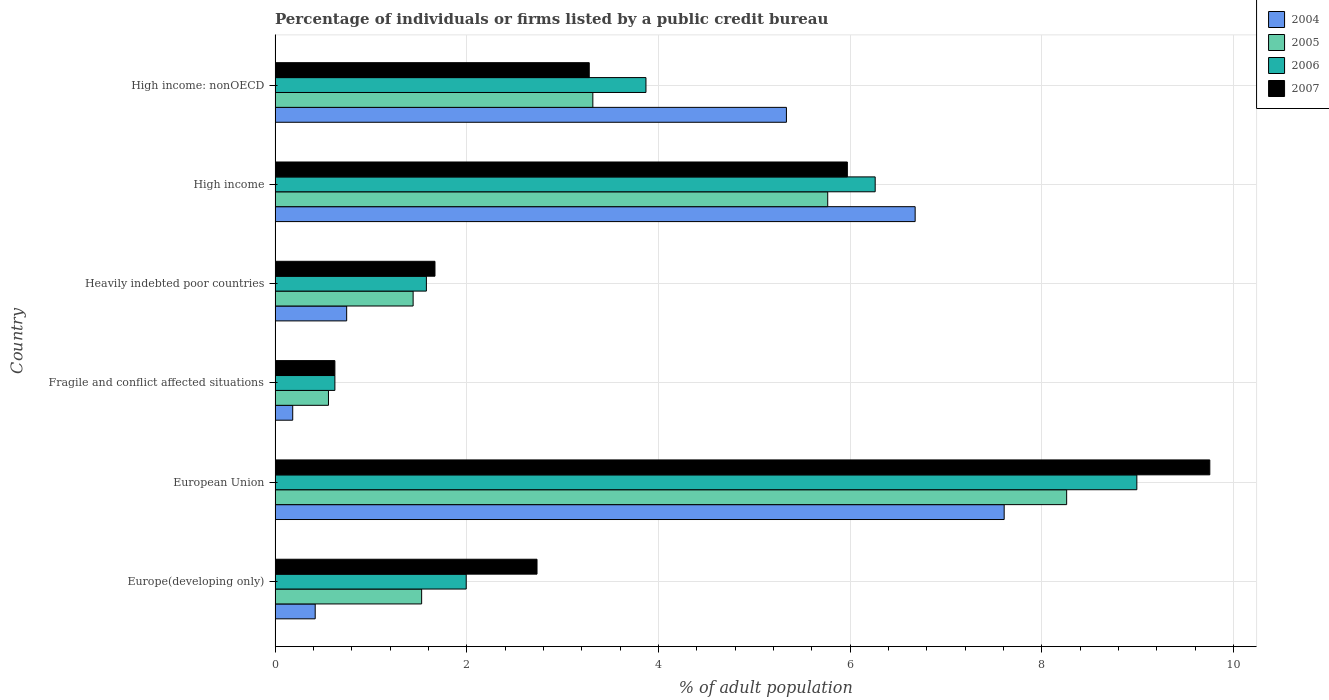Are the number of bars per tick equal to the number of legend labels?
Provide a short and direct response. Yes. Are the number of bars on each tick of the Y-axis equal?
Your response must be concise. Yes. How many bars are there on the 1st tick from the top?
Provide a succinct answer. 4. What is the label of the 6th group of bars from the top?
Provide a short and direct response. Europe(developing only). In how many cases, is the number of bars for a given country not equal to the number of legend labels?
Give a very brief answer. 0. What is the percentage of population listed by a public credit bureau in 2005 in High income: nonOECD?
Your response must be concise. 3.32. Across all countries, what is the maximum percentage of population listed by a public credit bureau in 2004?
Give a very brief answer. 7.61. Across all countries, what is the minimum percentage of population listed by a public credit bureau in 2007?
Your answer should be very brief. 0.62. In which country was the percentage of population listed by a public credit bureau in 2004 minimum?
Make the answer very short. Fragile and conflict affected situations. What is the total percentage of population listed by a public credit bureau in 2006 in the graph?
Provide a short and direct response. 23.32. What is the difference between the percentage of population listed by a public credit bureau in 2005 in Europe(developing only) and that in European Union?
Your answer should be very brief. -6.73. What is the difference between the percentage of population listed by a public credit bureau in 2004 in Europe(developing only) and the percentage of population listed by a public credit bureau in 2007 in European Union?
Give a very brief answer. -9.34. What is the average percentage of population listed by a public credit bureau in 2005 per country?
Provide a succinct answer. 3.48. What is the difference between the percentage of population listed by a public credit bureau in 2005 and percentage of population listed by a public credit bureau in 2004 in High income: nonOECD?
Provide a short and direct response. -2.02. What is the ratio of the percentage of population listed by a public credit bureau in 2004 in Europe(developing only) to that in Heavily indebted poor countries?
Your answer should be very brief. 0.56. Is the percentage of population listed by a public credit bureau in 2005 in European Union less than that in High income?
Offer a very short reply. No. What is the difference between the highest and the second highest percentage of population listed by a public credit bureau in 2007?
Your answer should be compact. 3.78. What is the difference between the highest and the lowest percentage of population listed by a public credit bureau in 2005?
Provide a short and direct response. 7.7. Is it the case that in every country, the sum of the percentage of population listed by a public credit bureau in 2006 and percentage of population listed by a public credit bureau in 2007 is greater than the sum of percentage of population listed by a public credit bureau in 2004 and percentage of population listed by a public credit bureau in 2005?
Offer a very short reply. No. What does the 4th bar from the bottom in Europe(developing only) represents?
Keep it short and to the point. 2007. How many bars are there?
Provide a short and direct response. 24. What is the difference between two consecutive major ticks on the X-axis?
Provide a short and direct response. 2. Are the values on the major ticks of X-axis written in scientific E-notation?
Provide a succinct answer. No. Does the graph contain grids?
Make the answer very short. Yes. What is the title of the graph?
Keep it short and to the point. Percentage of individuals or firms listed by a public credit bureau. What is the label or title of the X-axis?
Make the answer very short. % of adult population. What is the % of adult population in 2004 in Europe(developing only)?
Offer a very short reply. 0.42. What is the % of adult population of 2005 in Europe(developing only)?
Your answer should be compact. 1.53. What is the % of adult population in 2006 in Europe(developing only)?
Offer a very short reply. 1.99. What is the % of adult population in 2007 in Europe(developing only)?
Provide a short and direct response. 2.73. What is the % of adult population in 2004 in European Union?
Give a very brief answer. 7.61. What is the % of adult population in 2005 in European Union?
Offer a very short reply. 8.26. What is the % of adult population of 2006 in European Union?
Provide a short and direct response. 8.99. What is the % of adult population of 2007 in European Union?
Provide a succinct answer. 9.75. What is the % of adult population in 2004 in Fragile and conflict affected situations?
Ensure brevity in your answer.  0.18. What is the % of adult population in 2005 in Fragile and conflict affected situations?
Offer a very short reply. 0.56. What is the % of adult population in 2006 in Fragile and conflict affected situations?
Your answer should be very brief. 0.62. What is the % of adult population in 2007 in Fragile and conflict affected situations?
Provide a short and direct response. 0.62. What is the % of adult population in 2004 in Heavily indebted poor countries?
Provide a succinct answer. 0.75. What is the % of adult population of 2005 in Heavily indebted poor countries?
Give a very brief answer. 1.44. What is the % of adult population of 2006 in Heavily indebted poor countries?
Your response must be concise. 1.58. What is the % of adult population in 2007 in Heavily indebted poor countries?
Your response must be concise. 1.67. What is the % of adult population in 2004 in High income?
Make the answer very short. 6.68. What is the % of adult population in 2005 in High income?
Your answer should be compact. 5.77. What is the % of adult population in 2006 in High income?
Provide a short and direct response. 6.26. What is the % of adult population of 2007 in High income?
Make the answer very short. 5.97. What is the % of adult population of 2004 in High income: nonOECD?
Provide a short and direct response. 5.34. What is the % of adult population in 2005 in High income: nonOECD?
Offer a very short reply. 3.32. What is the % of adult population of 2006 in High income: nonOECD?
Your answer should be very brief. 3.87. What is the % of adult population of 2007 in High income: nonOECD?
Provide a succinct answer. 3.28. Across all countries, what is the maximum % of adult population in 2004?
Give a very brief answer. 7.61. Across all countries, what is the maximum % of adult population in 2005?
Provide a succinct answer. 8.26. Across all countries, what is the maximum % of adult population in 2006?
Ensure brevity in your answer.  8.99. Across all countries, what is the maximum % of adult population of 2007?
Your answer should be compact. 9.75. Across all countries, what is the minimum % of adult population of 2004?
Ensure brevity in your answer.  0.18. Across all countries, what is the minimum % of adult population of 2005?
Give a very brief answer. 0.56. Across all countries, what is the minimum % of adult population of 2006?
Offer a very short reply. 0.62. Across all countries, what is the minimum % of adult population of 2007?
Ensure brevity in your answer.  0.62. What is the total % of adult population in 2004 in the graph?
Your answer should be compact. 20.97. What is the total % of adult population in 2005 in the graph?
Offer a very short reply. 20.87. What is the total % of adult population in 2006 in the graph?
Offer a terse response. 23.32. What is the total % of adult population in 2007 in the graph?
Your answer should be very brief. 24.03. What is the difference between the % of adult population of 2004 in Europe(developing only) and that in European Union?
Ensure brevity in your answer.  -7.19. What is the difference between the % of adult population of 2005 in Europe(developing only) and that in European Union?
Your answer should be very brief. -6.73. What is the difference between the % of adult population of 2006 in Europe(developing only) and that in European Union?
Ensure brevity in your answer.  -7. What is the difference between the % of adult population of 2007 in Europe(developing only) and that in European Union?
Your answer should be compact. -7.02. What is the difference between the % of adult population in 2004 in Europe(developing only) and that in Fragile and conflict affected situations?
Make the answer very short. 0.23. What is the difference between the % of adult population in 2005 in Europe(developing only) and that in Fragile and conflict affected situations?
Your response must be concise. 0.97. What is the difference between the % of adult population in 2006 in Europe(developing only) and that in Fragile and conflict affected situations?
Ensure brevity in your answer.  1.37. What is the difference between the % of adult population of 2007 in Europe(developing only) and that in Fragile and conflict affected situations?
Offer a very short reply. 2.11. What is the difference between the % of adult population of 2004 in Europe(developing only) and that in Heavily indebted poor countries?
Give a very brief answer. -0.33. What is the difference between the % of adult population in 2005 in Europe(developing only) and that in Heavily indebted poor countries?
Offer a terse response. 0.09. What is the difference between the % of adult population of 2006 in Europe(developing only) and that in Heavily indebted poor countries?
Provide a short and direct response. 0.42. What is the difference between the % of adult population in 2007 in Europe(developing only) and that in Heavily indebted poor countries?
Your answer should be compact. 1.06. What is the difference between the % of adult population in 2004 in Europe(developing only) and that in High income?
Provide a short and direct response. -6.26. What is the difference between the % of adult population in 2005 in Europe(developing only) and that in High income?
Your answer should be very brief. -4.24. What is the difference between the % of adult population in 2006 in Europe(developing only) and that in High income?
Ensure brevity in your answer.  -4.27. What is the difference between the % of adult population in 2007 in Europe(developing only) and that in High income?
Offer a very short reply. -3.24. What is the difference between the % of adult population of 2004 in Europe(developing only) and that in High income: nonOECD?
Provide a succinct answer. -4.92. What is the difference between the % of adult population in 2005 in Europe(developing only) and that in High income: nonOECD?
Offer a very short reply. -1.79. What is the difference between the % of adult population in 2006 in Europe(developing only) and that in High income: nonOECD?
Offer a very short reply. -1.88. What is the difference between the % of adult population in 2007 in Europe(developing only) and that in High income: nonOECD?
Your response must be concise. -0.54. What is the difference between the % of adult population of 2004 in European Union and that in Fragile and conflict affected situations?
Keep it short and to the point. 7.42. What is the difference between the % of adult population of 2005 in European Union and that in Fragile and conflict affected situations?
Provide a short and direct response. 7.7. What is the difference between the % of adult population of 2006 in European Union and that in Fragile and conflict affected situations?
Give a very brief answer. 8.37. What is the difference between the % of adult population of 2007 in European Union and that in Fragile and conflict affected situations?
Ensure brevity in your answer.  9.13. What is the difference between the % of adult population of 2004 in European Union and that in Heavily indebted poor countries?
Offer a very short reply. 6.86. What is the difference between the % of adult population of 2005 in European Union and that in Heavily indebted poor countries?
Make the answer very short. 6.82. What is the difference between the % of adult population of 2006 in European Union and that in Heavily indebted poor countries?
Offer a very short reply. 7.41. What is the difference between the % of adult population of 2007 in European Union and that in Heavily indebted poor countries?
Provide a short and direct response. 8.09. What is the difference between the % of adult population of 2004 in European Union and that in High income?
Give a very brief answer. 0.93. What is the difference between the % of adult population in 2005 in European Union and that in High income?
Your answer should be very brief. 2.49. What is the difference between the % of adult population in 2006 in European Union and that in High income?
Offer a very short reply. 2.73. What is the difference between the % of adult population of 2007 in European Union and that in High income?
Provide a short and direct response. 3.78. What is the difference between the % of adult population of 2004 in European Union and that in High income: nonOECD?
Make the answer very short. 2.27. What is the difference between the % of adult population of 2005 in European Union and that in High income: nonOECD?
Your answer should be compact. 4.94. What is the difference between the % of adult population of 2006 in European Union and that in High income: nonOECD?
Provide a short and direct response. 5.12. What is the difference between the % of adult population in 2007 in European Union and that in High income: nonOECD?
Provide a succinct answer. 6.48. What is the difference between the % of adult population in 2004 in Fragile and conflict affected situations and that in Heavily indebted poor countries?
Offer a very short reply. -0.56. What is the difference between the % of adult population of 2005 in Fragile and conflict affected situations and that in Heavily indebted poor countries?
Provide a succinct answer. -0.88. What is the difference between the % of adult population of 2006 in Fragile and conflict affected situations and that in Heavily indebted poor countries?
Keep it short and to the point. -0.95. What is the difference between the % of adult population in 2007 in Fragile and conflict affected situations and that in Heavily indebted poor countries?
Ensure brevity in your answer.  -1.04. What is the difference between the % of adult population of 2004 in Fragile and conflict affected situations and that in High income?
Give a very brief answer. -6.5. What is the difference between the % of adult population of 2005 in Fragile and conflict affected situations and that in High income?
Your response must be concise. -5.21. What is the difference between the % of adult population in 2006 in Fragile and conflict affected situations and that in High income?
Provide a short and direct response. -5.64. What is the difference between the % of adult population of 2007 in Fragile and conflict affected situations and that in High income?
Offer a terse response. -5.35. What is the difference between the % of adult population of 2004 in Fragile and conflict affected situations and that in High income: nonOECD?
Offer a terse response. -5.15. What is the difference between the % of adult population in 2005 in Fragile and conflict affected situations and that in High income: nonOECD?
Make the answer very short. -2.76. What is the difference between the % of adult population in 2006 in Fragile and conflict affected situations and that in High income: nonOECD?
Keep it short and to the point. -3.25. What is the difference between the % of adult population of 2007 in Fragile and conflict affected situations and that in High income: nonOECD?
Provide a short and direct response. -2.65. What is the difference between the % of adult population of 2004 in Heavily indebted poor countries and that in High income?
Make the answer very short. -5.93. What is the difference between the % of adult population in 2005 in Heavily indebted poor countries and that in High income?
Provide a short and direct response. -4.33. What is the difference between the % of adult population in 2006 in Heavily indebted poor countries and that in High income?
Provide a succinct answer. -4.68. What is the difference between the % of adult population in 2007 in Heavily indebted poor countries and that in High income?
Ensure brevity in your answer.  -4.3. What is the difference between the % of adult population of 2004 in Heavily indebted poor countries and that in High income: nonOECD?
Provide a succinct answer. -4.59. What is the difference between the % of adult population in 2005 in Heavily indebted poor countries and that in High income: nonOECD?
Make the answer very short. -1.88. What is the difference between the % of adult population in 2006 in Heavily indebted poor countries and that in High income: nonOECD?
Give a very brief answer. -2.29. What is the difference between the % of adult population in 2007 in Heavily indebted poor countries and that in High income: nonOECD?
Offer a terse response. -1.61. What is the difference between the % of adult population in 2004 in High income and that in High income: nonOECD?
Offer a terse response. 1.34. What is the difference between the % of adult population of 2005 in High income and that in High income: nonOECD?
Your response must be concise. 2.45. What is the difference between the % of adult population in 2006 in High income and that in High income: nonOECD?
Make the answer very short. 2.39. What is the difference between the % of adult population of 2007 in High income and that in High income: nonOECD?
Ensure brevity in your answer.  2.69. What is the difference between the % of adult population of 2004 in Europe(developing only) and the % of adult population of 2005 in European Union?
Your answer should be compact. -7.84. What is the difference between the % of adult population in 2004 in Europe(developing only) and the % of adult population in 2006 in European Union?
Offer a terse response. -8.57. What is the difference between the % of adult population of 2004 in Europe(developing only) and the % of adult population of 2007 in European Union?
Make the answer very short. -9.34. What is the difference between the % of adult population in 2005 in Europe(developing only) and the % of adult population in 2006 in European Union?
Offer a terse response. -7.46. What is the difference between the % of adult population of 2005 in Europe(developing only) and the % of adult population of 2007 in European Union?
Offer a very short reply. -8.22. What is the difference between the % of adult population in 2006 in Europe(developing only) and the % of adult population in 2007 in European Union?
Offer a terse response. -7.76. What is the difference between the % of adult population in 2004 in Europe(developing only) and the % of adult population in 2005 in Fragile and conflict affected situations?
Provide a succinct answer. -0.14. What is the difference between the % of adult population in 2004 in Europe(developing only) and the % of adult population in 2006 in Fragile and conflict affected situations?
Make the answer very short. -0.21. What is the difference between the % of adult population of 2004 in Europe(developing only) and the % of adult population of 2007 in Fragile and conflict affected situations?
Provide a succinct answer. -0.21. What is the difference between the % of adult population of 2005 in Europe(developing only) and the % of adult population of 2006 in Fragile and conflict affected situations?
Keep it short and to the point. 0.91. What is the difference between the % of adult population in 2005 in Europe(developing only) and the % of adult population in 2007 in Fragile and conflict affected situations?
Give a very brief answer. 0.91. What is the difference between the % of adult population of 2006 in Europe(developing only) and the % of adult population of 2007 in Fragile and conflict affected situations?
Offer a very short reply. 1.37. What is the difference between the % of adult population in 2004 in Europe(developing only) and the % of adult population in 2005 in Heavily indebted poor countries?
Provide a short and direct response. -1.02. What is the difference between the % of adult population in 2004 in Europe(developing only) and the % of adult population in 2006 in Heavily indebted poor countries?
Offer a very short reply. -1.16. What is the difference between the % of adult population of 2004 in Europe(developing only) and the % of adult population of 2007 in Heavily indebted poor countries?
Give a very brief answer. -1.25. What is the difference between the % of adult population in 2005 in Europe(developing only) and the % of adult population in 2006 in Heavily indebted poor countries?
Your answer should be very brief. -0.05. What is the difference between the % of adult population in 2005 in Europe(developing only) and the % of adult population in 2007 in Heavily indebted poor countries?
Provide a short and direct response. -0.14. What is the difference between the % of adult population in 2006 in Europe(developing only) and the % of adult population in 2007 in Heavily indebted poor countries?
Provide a succinct answer. 0.33. What is the difference between the % of adult population in 2004 in Europe(developing only) and the % of adult population in 2005 in High income?
Your answer should be very brief. -5.35. What is the difference between the % of adult population in 2004 in Europe(developing only) and the % of adult population in 2006 in High income?
Offer a very short reply. -5.84. What is the difference between the % of adult population in 2004 in Europe(developing only) and the % of adult population in 2007 in High income?
Make the answer very short. -5.55. What is the difference between the % of adult population in 2005 in Europe(developing only) and the % of adult population in 2006 in High income?
Your response must be concise. -4.73. What is the difference between the % of adult population in 2005 in Europe(developing only) and the % of adult population in 2007 in High income?
Offer a terse response. -4.44. What is the difference between the % of adult population in 2006 in Europe(developing only) and the % of adult population in 2007 in High income?
Offer a very short reply. -3.98. What is the difference between the % of adult population of 2004 in Europe(developing only) and the % of adult population of 2005 in High income: nonOECD?
Your answer should be compact. -2.9. What is the difference between the % of adult population of 2004 in Europe(developing only) and the % of adult population of 2006 in High income: nonOECD?
Keep it short and to the point. -3.45. What is the difference between the % of adult population in 2004 in Europe(developing only) and the % of adult population in 2007 in High income: nonOECD?
Keep it short and to the point. -2.86. What is the difference between the % of adult population in 2005 in Europe(developing only) and the % of adult population in 2006 in High income: nonOECD?
Offer a terse response. -2.34. What is the difference between the % of adult population in 2005 in Europe(developing only) and the % of adult population in 2007 in High income: nonOECD?
Provide a short and direct response. -1.75. What is the difference between the % of adult population in 2006 in Europe(developing only) and the % of adult population in 2007 in High income: nonOECD?
Keep it short and to the point. -1.28. What is the difference between the % of adult population in 2004 in European Union and the % of adult population in 2005 in Fragile and conflict affected situations?
Make the answer very short. 7.05. What is the difference between the % of adult population in 2004 in European Union and the % of adult population in 2006 in Fragile and conflict affected situations?
Offer a terse response. 6.98. What is the difference between the % of adult population in 2004 in European Union and the % of adult population in 2007 in Fragile and conflict affected situations?
Ensure brevity in your answer.  6.98. What is the difference between the % of adult population of 2005 in European Union and the % of adult population of 2006 in Fragile and conflict affected situations?
Your answer should be very brief. 7.64. What is the difference between the % of adult population in 2005 in European Union and the % of adult population in 2007 in Fragile and conflict affected situations?
Your answer should be compact. 7.64. What is the difference between the % of adult population of 2006 in European Union and the % of adult population of 2007 in Fragile and conflict affected situations?
Give a very brief answer. 8.37. What is the difference between the % of adult population in 2004 in European Union and the % of adult population in 2005 in Heavily indebted poor countries?
Provide a succinct answer. 6.17. What is the difference between the % of adult population in 2004 in European Union and the % of adult population in 2006 in Heavily indebted poor countries?
Provide a short and direct response. 6.03. What is the difference between the % of adult population in 2004 in European Union and the % of adult population in 2007 in Heavily indebted poor countries?
Your answer should be compact. 5.94. What is the difference between the % of adult population of 2005 in European Union and the % of adult population of 2006 in Heavily indebted poor countries?
Give a very brief answer. 6.68. What is the difference between the % of adult population in 2005 in European Union and the % of adult population in 2007 in Heavily indebted poor countries?
Offer a terse response. 6.59. What is the difference between the % of adult population of 2006 in European Union and the % of adult population of 2007 in Heavily indebted poor countries?
Keep it short and to the point. 7.32. What is the difference between the % of adult population in 2004 in European Union and the % of adult population in 2005 in High income?
Provide a succinct answer. 1.84. What is the difference between the % of adult population of 2004 in European Union and the % of adult population of 2006 in High income?
Offer a very short reply. 1.35. What is the difference between the % of adult population of 2004 in European Union and the % of adult population of 2007 in High income?
Your answer should be very brief. 1.64. What is the difference between the % of adult population in 2005 in European Union and the % of adult population in 2006 in High income?
Ensure brevity in your answer.  2. What is the difference between the % of adult population in 2005 in European Union and the % of adult population in 2007 in High income?
Your response must be concise. 2.29. What is the difference between the % of adult population of 2006 in European Union and the % of adult population of 2007 in High income?
Provide a succinct answer. 3.02. What is the difference between the % of adult population of 2004 in European Union and the % of adult population of 2005 in High income: nonOECD?
Keep it short and to the point. 4.29. What is the difference between the % of adult population in 2004 in European Union and the % of adult population in 2006 in High income: nonOECD?
Your answer should be compact. 3.74. What is the difference between the % of adult population in 2004 in European Union and the % of adult population in 2007 in High income: nonOECD?
Give a very brief answer. 4.33. What is the difference between the % of adult population of 2005 in European Union and the % of adult population of 2006 in High income: nonOECD?
Your answer should be compact. 4.39. What is the difference between the % of adult population in 2005 in European Union and the % of adult population in 2007 in High income: nonOECD?
Ensure brevity in your answer.  4.98. What is the difference between the % of adult population in 2006 in European Union and the % of adult population in 2007 in High income: nonOECD?
Your answer should be compact. 5.71. What is the difference between the % of adult population in 2004 in Fragile and conflict affected situations and the % of adult population in 2005 in Heavily indebted poor countries?
Offer a very short reply. -1.26. What is the difference between the % of adult population of 2004 in Fragile and conflict affected situations and the % of adult population of 2006 in Heavily indebted poor countries?
Keep it short and to the point. -1.39. What is the difference between the % of adult population of 2004 in Fragile and conflict affected situations and the % of adult population of 2007 in Heavily indebted poor countries?
Your answer should be very brief. -1.48. What is the difference between the % of adult population in 2005 in Fragile and conflict affected situations and the % of adult population in 2006 in Heavily indebted poor countries?
Your answer should be compact. -1.02. What is the difference between the % of adult population of 2005 in Fragile and conflict affected situations and the % of adult population of 2007 in Heavily indebted poor countries?
Give a very brief answer. -1.11. What is the difference between the % of adult population in 2006 in Fragile and conflict affected situations and the % of adult population in 2007 in Heavily indebted poor countries?
Make the answer very short. -1.04. What is the difference between the % of adult population in 2004 in Fragile and conflict affected situations and the % of adult population in 2005 in High income?
Offer a terse response. -5.58. What is the difference between the % of adult population in 2004 in Fragile and conflict affected situations and the % of adult population in 2006 in High income?
Give a very brief answer. -6.08. What is the difference between the % of adult population of 2004 in Fragile and conflict affected situations and the % of adult population of 2007 in High income?
Make the answer very short. -5.79. What is the difference between the % of adult population in 2005 in Fragile and conflict affected situations and the % of adult population in 2006 in High income?
Your response must be concise. -5.7. What is the difference between the % of adult population in 2005 in Fragile and conflict affected situations and the % of adult population in 2007 in High income?
Make the answer very short. -5.41. What is the difference between the % of adult population in 2006 in Fragile and conflict affected situations and the % of adult population in 2007 in High income?
Your answer should be compact. -5.35. What is the difference between the % of adult population of 2004 in Fragile and conflict affected situations and the % of adult population of 2005 in High income: nonOECD?
Ensure brevity in your answer.  -3.13. What is the difference between the % of adult population in 2004 in Fragile and conflict affected situations and the % of adult population in 2006 in High income: nonOECD?
Your response must be concise. -3.69. What is the difference between the % of adult population of 2004 in Fragile and conflict affected situations and the % of adult population of 2007 in High income: nonOECD?
Your answer should be very brief. -3.09. What is the difference between the % of adult population in 2005 in Fragile and conflict affected situations and the % of adult population in 2006 in High income: nonOECD?
Ensure brevity in your answer.  -3.31. What is the difference between the % of adult population of 2005 in Fragile and conflict affected situations and the % of adult population of 2007 in High income: nonOECD?
Your response must be concise. -2.72. What is the difference between the % of adult population of 2006 in Fragile and conflict affected situations and the % of adult population of 2007 in High income: nonOECD?
Provide a short and direct response. -2.65. What is the difference between the % of adult population of 2004 in Heavily indebted poor countries and the % of adult population of 2005 in High income?
Offer a terse response. -5.02. What is the difference between the % of adult population in 2004 in Heavily indebted poor countries and the % of adult population in 2006 in High income?
Provide a short and direct response. -5.51. What is the difference between the % of adult population of 2004 in Heavily indebted poor countries and the % of adult population of 2007 in High income?
Make the answer very short. -5.22. What is the difference between the % of adult population in 2005 in Heavily indebted poor countries and the % of adult population in 2006 in High income?
Ensure brevity in your answer.  -4.82. What is the difference between the % of adult population of 2005 in Heavily indebted poor countries and the % of adult population of 2007 in High income?
Ensure brevity in your answer.  -4.53. What is the difference between the % of adult population of 2006 in Heavily indebted poor countries and the % of adult population of 2007 in High income?
Keep it short and to the point. -4.39. What is the difference between the % of adult population of 2004 in Heavily indebted poor countries and the % of adult population of 2005 in High income: nonOECD?
Your response must be concise. -2.57. What is the difference between the % of adult population in 2004 in Heavily indebted poor countries and the % of adult population in 2006 in High income: nonOECD?
Provide a succinct answer. -3.12. What is the difference between the % of adult population in 2004 in Heavily indebted poor countries and the % of adult population in 2007 in High income: nonOECD?
Your answer should be compact. -2.53. What is the difference between the % of adult population of 2005 in Heavily indebted poor countries and the % of adult population of 2006 in High income: nonOECD?
Your answer should be compact. -2.43. What is the difference between the % of adult population in 2005 in Heavily indebted poor countries and the % of adult population in 2007 in High income: nonOECD?
Provide a succinct answer. -1.84. What is the difference between the % of adult population in 2006 in Heavily indebted poor countries and the % of adult population in 2007 in High income: nonOECD?
Make the answer very short. -1.7. What is the difference between the % of adult population in 2004 in High income and the % of adult population in 2005 in High income: nonOECD?
Your response must be concise. 3.36. What is the difference between the % of adult population of 2004 in High income and the % of adult population of 2006 in High income: nonOECD?
Offer a terse response. 2.81. What is the difference between the % of adult population of 2004 in High income and the % of adult population of 2007 in High income: nonOECD?
Your answer should be very brief. 3.4. What is the difference between the % of adult population in 2005 in High income and the % of adult population in 2006 in High income: nonOECD?
Your answer should be very brief. 1.9. What is the difference between the % of adult population in 2005 in High income and the % of adult population in 2007 in High income: nonOECD?
Make the answer very short. 2.49. What is the difference between the % of adult population in 2006 in High income and the % of adult population in 2007 in High income: nonOECD?
Offer a very short reply. 2.98. What is the average % of adult population in 2004 per country?
Make the answer very short. 3.5. What is the average % of adult population in 2005 per country?
Your answer should be very brief. 3.48. What is the average % of adult population of 2006 per country?
Your answer should be very brief. 3.89. What is the average % of adult population of 2007 per country?
Your answer should be compact. 4. What is the difference between the % of adult population of 2004 and % of adult population of 2005 in Europe(developing only)?
Provide a succinct answer. -1.11. What is the difference between the % of adult population in 2004 and % of adult population in 2006 in Europe(developing only)?
Offer a very short reply. -1.58. What is the difference between the % of adult population of 2004 and % of adult population of 2007 in Europe(developing only)?
Your response must be concise. -2.31. What is the difference between the % of adult population of 2005 and % of adult population of 2006 in Europe(developing only)?
Your answer should be very brief. -0.47. What is the difference between the % of adult population in 2005 and % of adult population in 2007 in Europe(developing only)?
Make the answer very short. -1.2. What is the difference between the % of adult population of 2006 and % of adult population of 2007 in Europe(developing only)?
Ensure brevity in your answer.  -0.74. What is the difference between the % of adult population in 2004 and % of adult population in 2005 in European Union?
Give a very brief answer. -0.65. What is the difference between the % of adult population in 2004 and % of adult population in 2006 in European Union?
Keep it short and to the point. -1.38. What is the difference between the % of adult population in 2004 and % of adult population in 2007 in European Union?
Offer a very short reply. -2.15. What is the difference between the % of adult population of 2005 and % of adult population of 2006 in European Union?
Your answer should be compact. -0.73. What is the difference between the % of adult population of 2005 and % of adult population of 2007 in European Union?
Make the answer very short. -1.49. What is the difference between the % of adult population in 2006 and % of adult population in 2007 in European Union?
Ensure brevity in your answer.  -0.76. What is the difference between the % of adult population in 2004 and % of adult population in 2005 in Fragile and conflict affected situations?
Make the answer very short. -0.37. What is the difference between the % of adult population of 2004 and % of adult population of 2006 in Fragile and conflict affected situations?
Your response must be concise. -0.44. What is the difference between the % of adult population of 2004 and % of adult population of 2007 in Fragile and conflict affected situations?
Offer a terse response. -0.44. What is the difference between the % of adult population in 2005 and % of adult population in 2006 in Fragile and conflict affected situations?
Provide a succinct answer. -0.07. What is the difference between the % of adult population of 2005 and % of adult population of 2007 in Fragile and conflict affected situations?
Ensure brevity in your answer.  -0.07. What is the difference between the % of adult population of 2006 and % of adult population of 2007 in Fragile and conflict affected situations?
Offer a terse response. 0. What is the difference between the % of adult population of 2004 and % of adult population of 2005 in Heavily indebted poor countries?
Keep it short and to the point. -0.69. What is the difference between the % of adult population in 2004 and % of adult population in 2006 in Heavily indebted poor countries?
Ensure brevity in your answer.  -0.83. What is the difference between the % of adult population of 2004 and % of adult population of 2007 in Heavily indebted poor countries?
Your answer should be very brief. -0.92. What is the difference between the % of adult population in 2005 and % of adult population in 2006 in Heavily indebted poor countries?
Offer a very short reply. -0.14. What is the difference between the % of adult population of 2005 and % of adult population of 2007 in Heavily indebted poor countries?
Your answer should be very brief. -0.23. What is the difference between the % of adult population in 2006 and % of adult population in 2007 in Heavily indebted poor countries?
Your answer should be compact. -0.09. What is the difference between the % of adult population of 2004 and % of adult population of 2005 in High income?
Ensure brevity in your answer.  0.91. What is the difference between the % of adult population in 2004 and % of adult population in 2006 in High income?
Provide a succinct answer. 0.42. What is the difference between the % of adult population of 2004 and % of adult population of 2007 in High income?
Provide a short and direct response. 0.71. What is the difference between the % of adult population in 2005 and % of adult population in 2006 in High income?
Offer a very short reply. -0.5. What is the difference between the % of adult population in 2005 and % of adult population in 2007 in High income?
Keep it short and to the point. -0.2. What is the difference between the % of adult population of 2006 and % of adult population of 2007 in High income?
Provide a short and direct response. 0.29. What is the difference between the % of adult population of 2004 and % of adult population of 2005 in High income: nonOECD?
Your answer should be very brief. 2.02. What is the difference between the % of adult population in 2004 and % of adult population in 2006 in High income: nonOECD?
Your response must be concise. 1.47. What is the difference between the % of adult population in 2004 and % of adult population in 2007 in High income: nonOECD?
Give a very brief answer. 2.06. What is the difference between the % of adult population of 2005 and % of adult population of 2006 in High income: nonOECD?
Provide a succinct answer. -0.55. What is the difference between the % of adult population of 2005 and % of adult population of 2007 in High income: nonOECD?
Your response must be concise. 0.04. What is the difference between the % of adult population of 2006 and % of adult population of 2007 in High income: nonOECD?
Ensure brevity in your answer.  0.59. What is the ratio of the % of adult population of 2004 in Europe(developing only) to that in European Union?
Make the answer very short. 0.06. What is the ratio of the % of adult population of 2005 in Europe(developing only) to that in European Union?
Give a very brief answer. 0.19. What is the ratio of the % of adult population in 2006 in Europe(developing only) to that in European Union?
Offer a very short reply. 0.22. What is the ratio of the % of adult population in 2007 in Europe(developing only) to that in European Union?
Your response must be concise. 0.28. What is the ratio of the % of adult population in 2004 in Europe(developing only) to that in Fragile and conflict affected situations?
Give a very brief answer. 2.28. What is the ratio of the % of adult population in 2005 in Europe(developing only) to that in Fragile and conflict affected situations?
Make the answer very short. 2.75. What is the ratio of the % of adult population of 2006 in Europe(developing only) to that in Fragile and conflict affected situations?
Provide a short and direct response. 3.2. What is the ratio of the % of adult population of 2007 in Europe(developing only) to that in Fragile and conflict affected situations?
Your response must be concise. 4.38. What is the ratio of the % of adult population of 2004 in Europe(developing only) to that in Heavily indebted poor countries?
Offer a very short reply. 0.56. What is the ratio of the % of adult population in 2005 in Europe(developing only) to that in Heavily indebted poor countries?
Give a very brief answer. 1.06. What is the ratio of the % of adult population of 2006 in Europe(developing only) to that in Heavily indebted poor countries?
Offer a very short reply. 1.26. What is the ratio of the % of adult population of 2007 in Europe(developing only) to that in Heavily indebted poor countries?
Provide a short and direct response. 1.64. What is the ratio of the % of adult population of 2004 in Europe(developing only) to that in High income?
Keep it short and to the point. 0.06. What is the ratio of the % of adult population of 2005 in Europe(developing only) to that in High income?
Make the answer very short. 0.27. What is the ratio of the % of adult population in 2006 in Europe(developing only) to that in High income?
Provide a short and direct response. 0.32. What is the ratio of the % of adult population in 2007 in Europe(developing only) to that in High income?
Make the answer very short. 0.46. What is the ratio of the % of adult population in 2004 in Europe(developing only) to that in High income: nonOECD?
Ensure brevity in your answer.  0.08. What is the ratio of the % of adult population of 2005 in Europe(developing only) to that in High income: nonOECD?
Keep it short and to the point. 0.46. What is the ratio of the % of adult population of 2006 in Europe(developing only) to that in High income: nonOECD?
Ensure brevity in your answer.  0.52. What is the ratio of the % of adult population of 2007 in Europe(developing only) to that in High income: nonOECD?
Provide a succinct answer. 0.83. What is the ratio of the % of adult population of 2004 in European Union to that in Fragile and conflict affected situations?
Offer a terse response. 41.35. What is the ratio of the % of adult population of 2005 in European Union to that in Fragile and conflict affected situations?
Your answer should be compact. 14.83. What is the ratio of the % of adult population of 2006 in European Union to that in Fragile and conflict affected situations?
Offer a very short reply. 14.41. What is the ratio of the % of adult population in 2007 in European Union to that in Fragile and conflict affected situations?
Your answer should be compact. 15.63. What is the ratio of the % of adult population in 2004 in European Union to that in Heavily indebted poor countries?
Your answer should be compact. 10.18. What is the ratio of the % of adult population in 2005 in European Union to that in Heavily indebted poor countries?
Provide a short and direct response. 5.73. What is the ratio of the % of adult population of 2006 in European Union to that in Heavily indebted poor countries?
Give a very brief answer. 5.7. What is the ratio of the % of adult population of 2007 in European Union to that in Heavily indebted poor countries?
Ensure brevity in your answer.  5.85. What is the ratio of the % of adult population in 2004 in European Union to that in High income?
Your response must be concise. 1.14. What is the ratio of the % of adult population in 2005 in European Union to that in High income?
Provide a succinct answer. 1.43. What is the ratio of the % of adult population of 2006 in European Union to that in High income?
Provide a succinct answer. 1.44. What is the ratio of the % of adult population of 2007 in European Union to that in High income?
Offer a terse response. 1.63. What is the ratio of the % of adult population of 2004 in European Union to that in High income: nonOECD?
Offer a terse response. 1.43. What is the ratio of the % of adult population in 2005 in European Union to that in High income: nonOECD?
Offer a very short reply. 2.49. What is the ratio of the % of adult population in 2006 in European Union to that in High income: nonOECD?
Offer a very short reply. 2.32. What is the ratio of the % of adult population in 2007 in European Union to that in High income: nonOECD?
Offer a terse response. 2.98. What is the ratio of the % of adult population in 2004 in Fragile and conflict affected situations to that in Heavily indebted poor countries?
Give a very brief answer. 0.25. What is the ratio of the % of adult population of 2005 in Fragile and conflict affected situations to that in Heavily indebted poor countries?
Provide a short and direct response. 0.39. What is the ratio of the % of adult population in 2006 in Fragile and conflict affected situations to that in Heavily indebted poor countries?
Provide a short and direct response. 0.4. What is the ratio of the % of adult population in 2007 in Fragile and conflict affected situations to that in Heavily indebted poor countries?
Offer a very short reply. 0.37. What is the ratio of the % of adult population in 2004 in Fragile and conflict affected situations to that in High income?
Provide a short and direct response. 0.03. What is the ratio of the % of adult population of 2005 in Fragile and conflict affected situations to that in High income?
Keep it short and to the point. 0.1. What is the ratio of the % of adult population of 2006 in Fragile and conflict affected situations to that in High income?
Keep it short and to the point. 0.1. What is the ratio of the % of adult population in 2007 in Fragile and conflict affected situations to that in High income?
Keep it short and to the point. 0.1. What is the ratio of the % of adult population of 2004 in Fragile and conflict affected situations to that in High income: nonOECD?
Ensure brevity in your answer.  0.03. What is the ratio of the % of adult population in 2005 in Fragile and conflict affected situations to that in High income: nonOECD?
Make the answer very short. 0.17. What is the ratio of the % of adult population of 2006 in Fragile and conflict affected situations to that in High income: nonOECD?
Give a very brief answer. 0.16. What is the ratio of the % of adult population of 2007 in Fragile and conflict affected situations to that in High income: nonOECD?
Your answer should be compact. 0.19. What is the ratio of the % of adult population of 2004 in Heavily indebted poor countries to that in High income?
Give a very brief answer. 0.11. What is the ratio of the % of adult population of 2005 in Heavily indebted poor countries to that in High income?
Ensure brevity in your answer.  0.25. What is the ratio of the % of adult population of 2006 in Heavily indebted poor countries to that in High income?
Give a very brief answer. 0.25. What is the ratio of the % of adult population in 2007 in Heavily indebted poor countries to that in High income?
Keep it short and to the point. 0.28. What is the ratio of the % of adult population in 2004 in Heavily indebted poor countries to that in High income: nonOECD?
Ensure brevity in your answer.  0.14. What is the ratio of the % of adult population of 2005 in Heavily indebted poor countries to that in High income: nonOECD?
Ensure brevity in your answer.  0.43. What is the ratio of the % of adult population of 2006 in Heavily indebted poor countries to that in High income: nonOECD?
Offer a very short reply. 0.41. What is the ratio of the % of adult population in 2007 in Heavily indebted poor countries to that in High income: nonOECD?
Offer a very short reply. 0.51. What is the ratio of the % of adult population of 2004 in High income to that in High income: nonOECD?
Make the answer very short. 1.25. What is the ratio of the % of adult population of 2005 in High income to that in High income: nonOECD?
Give a very brief answer. 1.74. What is the ratio of the % of adult population in 2006 in High income to that in High income: nonOECD?
Give a very brief answer. 1.62. What is the ratio of the % of adult population in 2007 in High income to that in High income: nonOECD?
Provide a short and direct response. 1.82. What is the difference between the highest and the second highest % of adult population of 2004?
Your answer should be very brief. 0.93. What is the difference between the highest and the second highest % of adult population in 2005?
Offer a terse response. 2.49. What is the difference between the highest and the second highest % of adult population of 2006?
Keep it short and to the point. 2.73. What is the difference between the highest and the second highest % of adult population of 2007?
Ensure brevity in your answer.  3.78. What is the difference between the highest and the lowest % of adult population in 2004?
Provide a short and direct response. 7.42. What is the difference between the highest and the lowest % of adult population of 2005?
Provide a short and direct response. 7.7. What is the difference between the highest and the lowest % of adult population of 2006?
Your answer should be compact. 8.37. What is the difference between the highest and the lowest % of adult population in 2007?
Keep it short and to the point. 9.13. 